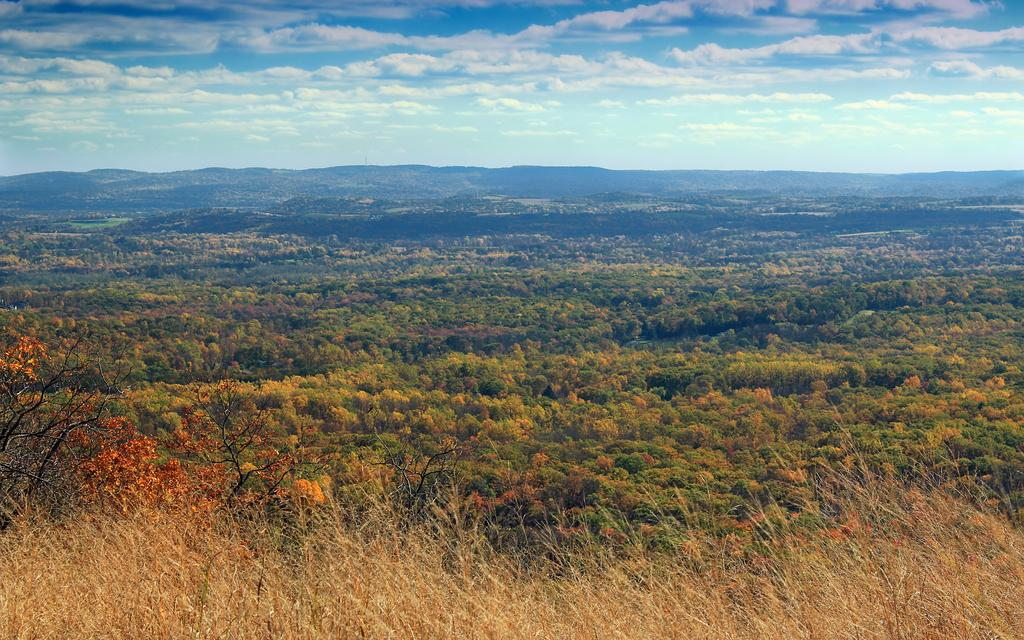What type of vegetation is present in the image? There are many trees and plants in the image. What is the condition of the grass at the bottom of the image? The grass at the bottom of the image is dry. What can be seen in the background of the image? There are mountains visible in the background of the image. What is visible in the sky at the top of the image? There are clouds in the sky at the top of the image. What type of umbrella is being used to protect the trees from the loss in the image? There is no umbrella or loss mentioned in the image; it features trees, plants, dry grass, mountains, and clouds. 